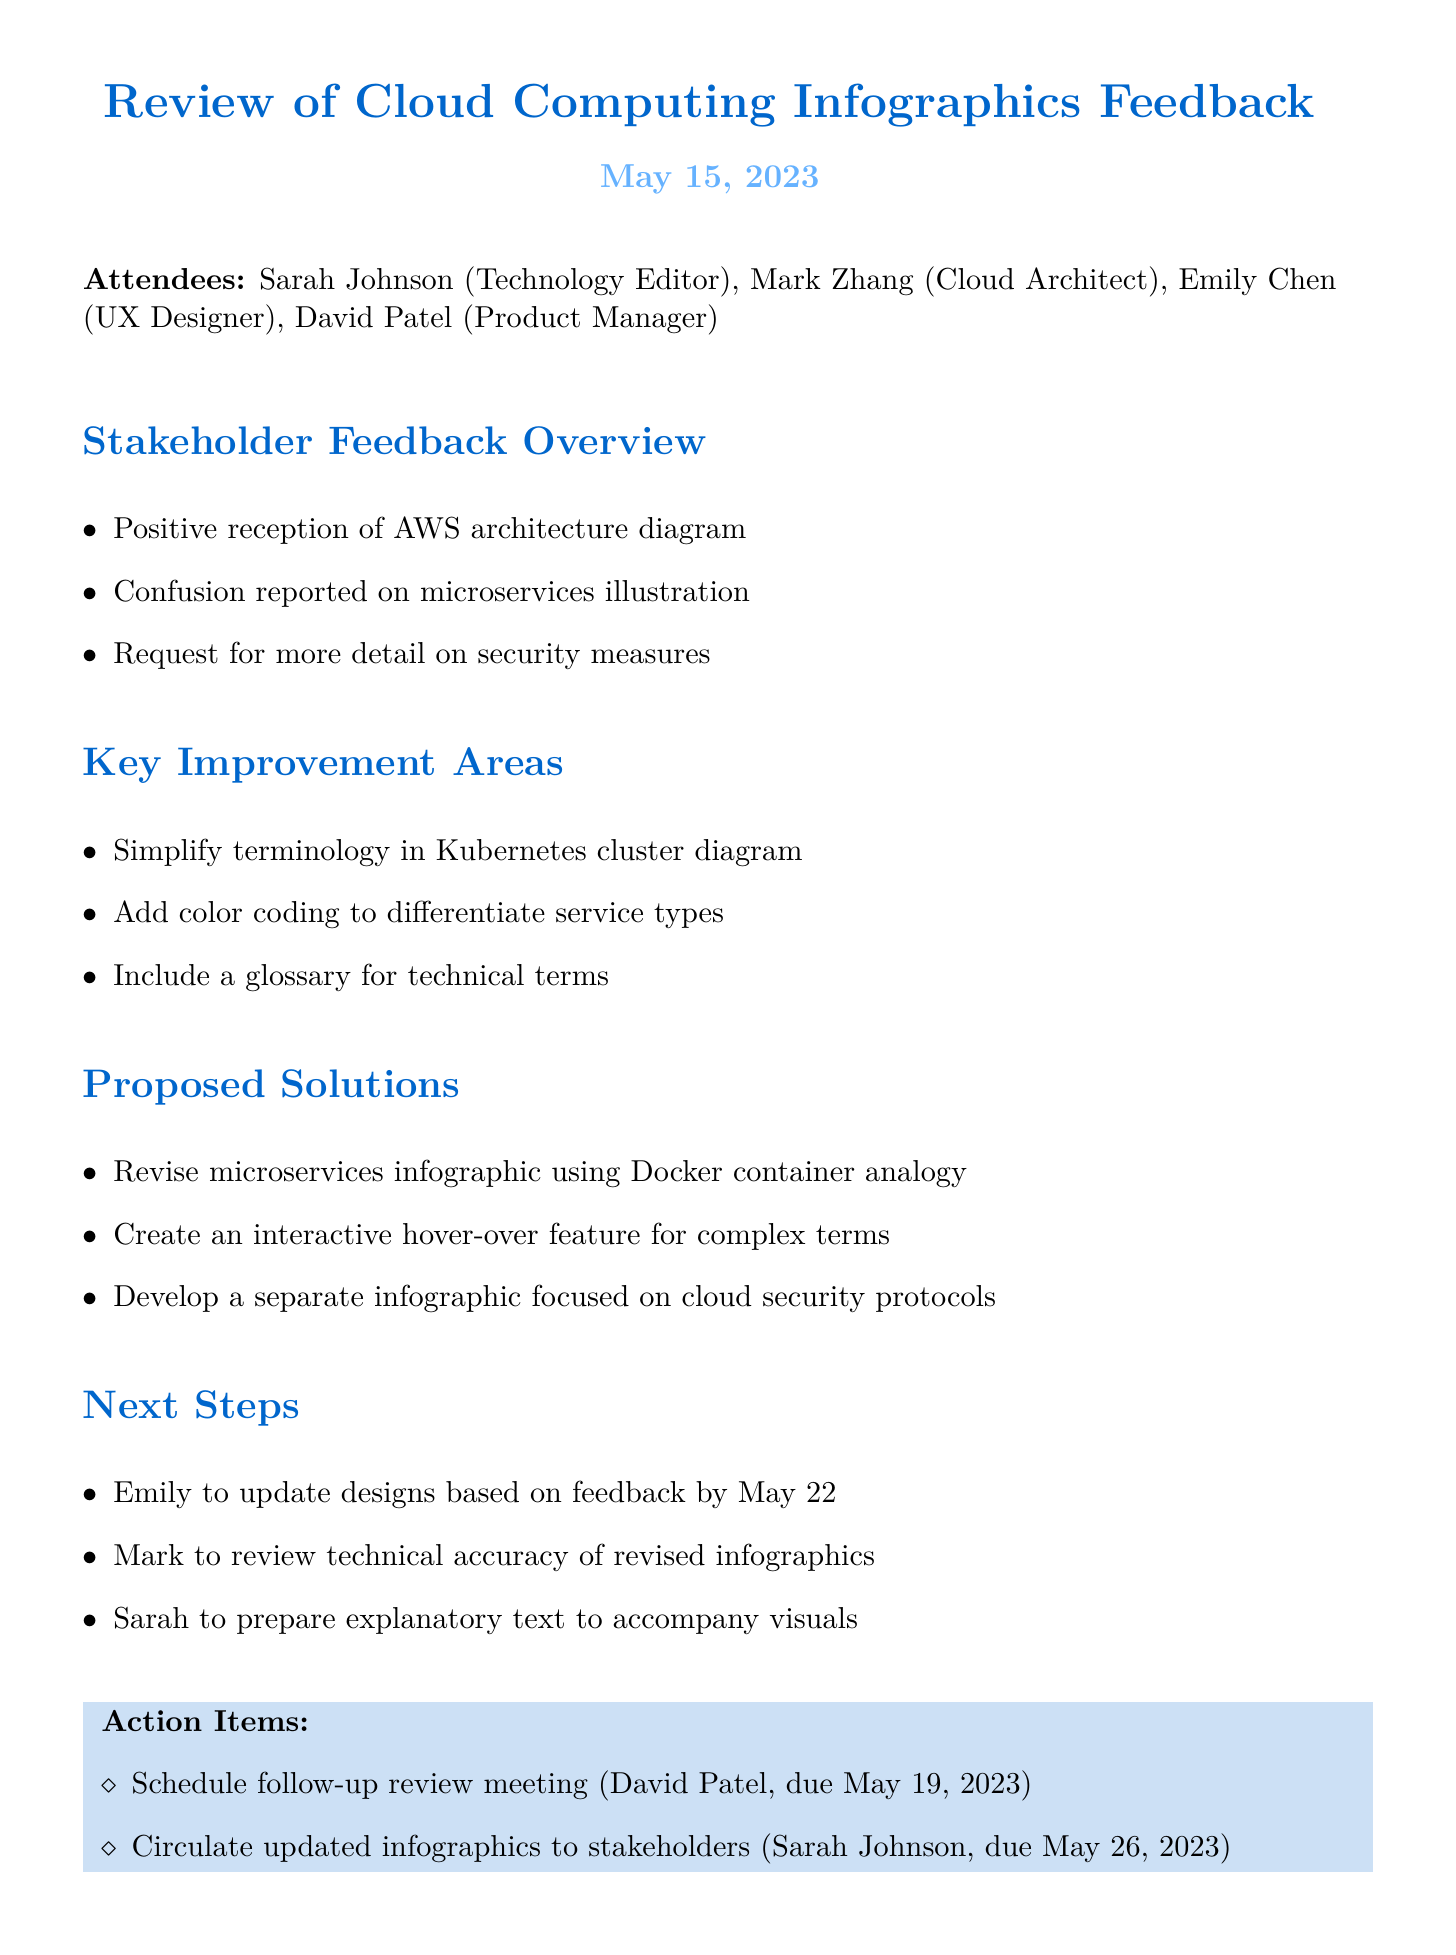What is the meeting title? The meeting title is mentioned at the beginning of the document to summarize the discussion topic.
Answer: Review of Cloud Computing Infographics Feedback Who requested more detail on security measures? The document lists specific feedback points from stakeholders, including a request for details on security measures.
Answer: Stakeholders When is Emily expected to update the designs? The next steps outline the due dates for various tasks, including Emily's design updates.
Answer: May 22 What is one of the proposed solutions for the microservices infographic? The document provides suggestions for improving the infographics, including a specific revision approach for microservices.
Answer: Revise microservices infographic using Docker container analogy Who is responsible for scheduling the follow-up review meeting? The action items clearly assign specific tasks to attendees, including scheduling the next review meeting.
Answer: David Patel What type of infographics is needed to focus on cloud security? The proposed solutions include a specific infographic to address a particular aspect of cloud computing.
Answer: Separate infographic focused on cloud security protocols 